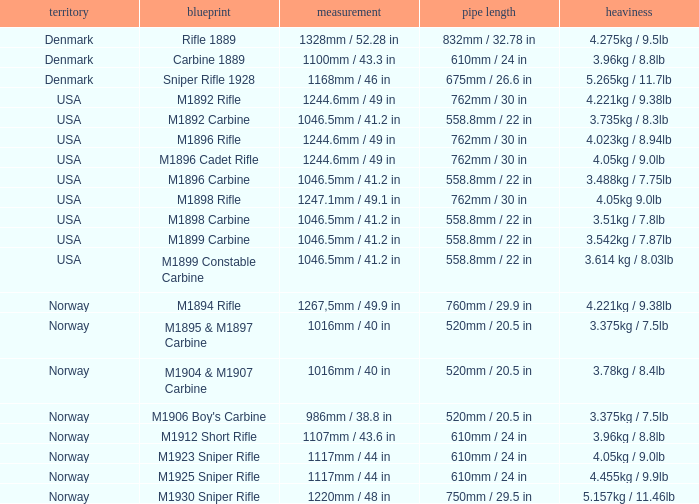What is Weight, when Length is 1168mm / 46 in? 5.265kg / 11.7lb. 